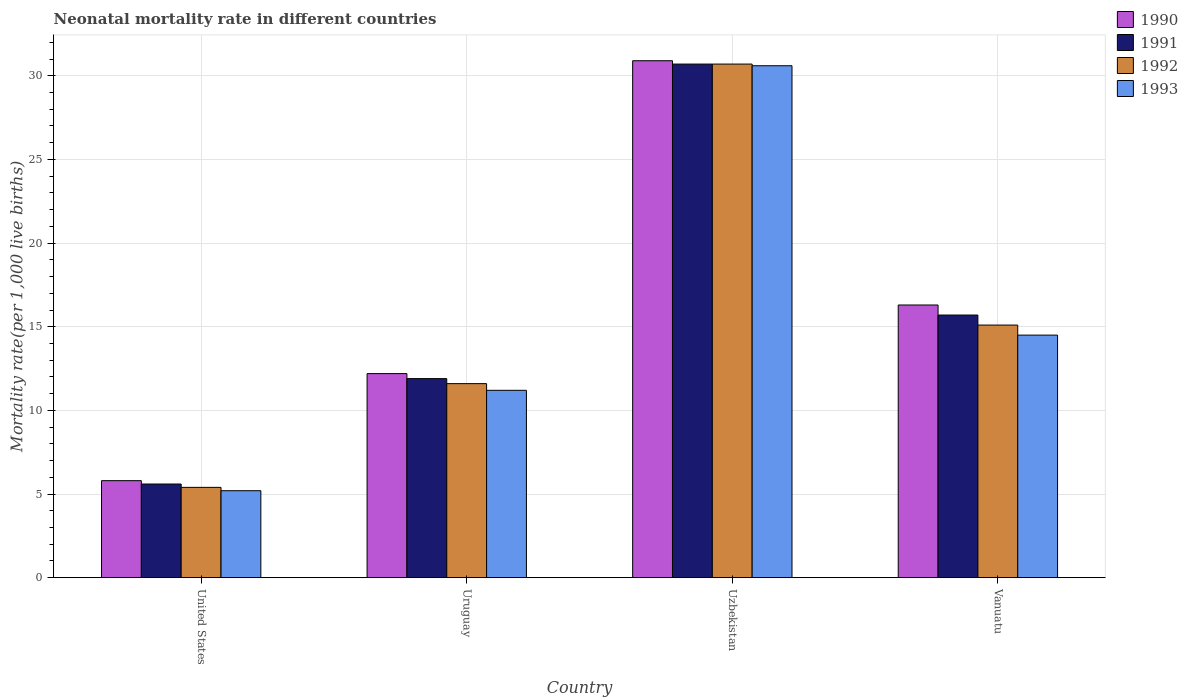Are the number of bars per tick equal to the number of legend labels?
Keep it short and to the point. Yes. What is the label of the 4th group of bars from the left?
Offer a very short reply. Vanuatu. In how many cases, is the number of bars for a given country not equal to the number of legend labels?
Keep it short and to the point. 0. Across all countries, what is the maximum neonatal mortality rate in 1992?
Give a very brief answer. 30.7. In which country was the neonatal mortality rate in 1991 maximum?
Provide a succinct answer. Uzbekistan. What is the total neonatal mortality rate in 1990 in the graph?
Give a very brief answer. 65.2. What is the difference between the neonatal mortality rate in 1992 in United States and that in Uruguay?
Your response must be concise. -6.2. What is the difference between the neonatal mortality rate in 1993 in Uruguay and the neonatal mortality rate in 1991 in United States?
Offer a terse response. 5.6. What is the average neonatal mortality rate in 1993 per country?
Give a very brief answer. 15.38. What is the difference between the neonatal mortality rate of/in 1990 and neonatal mortality rate of/in 1991 in United States?
Offer a terse response. 0.2. In how many countries, is the neonatal mortality rate in 1992 greater than 5?
Make the answer very short. 4. What is the ratio of the neonatal mortality rate in 1991 in United States to that in Uruguay?
Keep it short and to the point. 0.47. Is the neonatal mortality rate in 1990 in United States less than that in Uruguay?
Keep it short and to the point. Yes. Is the difference between the neonatal mortality rate in 1990 in United States and Uzbekistan greater than the difference between the neonatal mortality rate in 1991 in United States and Uzbekistan?
Your answer should be very brief. Yes. What is the difference between the highest and the second highest neonatal mortality rate in 1991?
Your answer should be compact. -18.8. What is the difference between the highest and the lowest neonatal mortality rate in 1991?
Your answer should be compact. 25.1. Is it the case that in every country, the sum of the neonatal mortality rate in 1990 and neonatal mortality rate in 1993 is greater than the sum of neonatal mortality rate in 1992 and neonatal mortality rate in 1991?
Offer a very short reply. No. Is it the case that in every country, the sum of the neonatal mortality rate in 1992 and neonatal mortality rate in 1990 is greater than the neonatal mortality rate in 1993?
Make the answer very short. Yes. How many countries are there in the graph?
Ensure brevity in your answer.  4. What is the difference between two consecutive major ticks on the Y-axis?
Offer a terse response. 5. Are the values on the major ticks of Y-axis written in scientific E-notation?
Offer a very short reply. No. Does the graph contain grids?
Keep it short and to the point. Yes. How many legend labels are there?
Your response must be concise. 4. How are the legend labels stacked?
Provide a short and direct response. Vertical. What is the title of the graph?
Offer a very short reply. Neonatal mortality rate in different countries. What is the label or title of the Y-axis?
Provide a short and direct response. Mortality rate(per 1,0 live births). What is the Mortality rate(per 1,000 live births) of 1991 in United States?
Provide a short and direct response. 5.6. What is the Mortality rate(per 1,000 live births) of 1992 in United States?
Provide a succinct answer. 5.4. What is the Mortality rate(per 1,000 live births) in 1993 in United States?
Keep it short and to the point. 5.2. What is the Mortality rate(per 1,000 live births) of 1991 in Uruguay?
Your answer should be very brief. 11.9. What is the Mortality rate(per 1,000 live births) in 1993 in Uruguay?
Offer a terse response. 11.2. What is the Mortality rate(per 1,000 live births) in 1990 in Uzbekistan?
Provide a short and direct response. 30.9. What is the Mortality rate(per 1,000 live births) of 1991 in Uzbekistan?
Offer a terse response. 30.7. What is the Mortality rate(per 1,000 live births) of 1992 in Uzbekistan?
Your answer should be very brief. 30.7. What is the Mortality rate(per 1,000 live births) of 1993 in Uzbekistan?
Provide a short and direct response. 30.6. What is the Mortality rate(per 1,000 live births) of 1991 in Vanuatu?
Provide a succinct answer. 15.7. What is the Mortality rate(per 1,000 live births) of 1992 in Vanuatu?
Give a very brief answer. 15.1. What is the Mortality rate(per 1,000 live births) in 1993 in Vanuatu?
Keep it short and to the point. 14.5. Across all countries, what is the maximum Mortality rate(per 1,000 live births) of 1990?
Provide a short and direct response. 30.9. Across all countries, what is the maximum Mortality rate(per 1,000 live births) of 1991?
Offer a very short reply. 30.7. Across all countries, what is the maximum Mortality rate(per 1,000 live births) in 1992?
Offer a terse response. 30.7. Across all countries, what is the maximum Mortality rate(per 1,000 live births) in 1993?
Your answer should be very brief. 30.6. Across all countries, what is the minimum Mortality rate(per 1,000 live births) of 1992?
Your response must be concise. 5.4. What is the total Mortality rate(per 1,000 live births) of 1990 in the graph?
Offer a very short reply. 65.2. What is the total Mortality rate(per 1,000 live births) in 1991 in the graph?
Your answer should be very brief. 63.9. What is the total Mortality rate(per 1,000 live births) in 1992 in the graph?
Keep it short and to the point. 62.8. What is the total Mortality rate(per 1,000 live births) in 1993 in the graph?
Offer a very short reply. 61.5. What is the difference between the Mortality rate(per 1,000 live births) in 1990 in United States and that in Uzbekistan?
Your answer should be compact. -25.1. What is the difference between the Mortality rate(per 1,000 live births) in 1991 in United States and that in Uzbekistan?
Your response must be concise. -25.1. What is the difference between the Mortality rate(per 1,000 live births) of 1992 in United States and that in Uzbekistan?
Your answer should be very brief. -25.3. What is the difference between the Mortality rate(per 1,000 live births) in 1993 in United States and that in Uzbekistan?
Ensure brevity in your answer.  -25.4. What is the difference between the Mortality rate(per 1,000 live births) of 1990 in United States and that in Vanuatu?
Your response must be concise. -10.5. What is the difference between the Mortality rate(per 1,000 live births) of 1990 in Uruguay and that in Uzbekistan?
Provide a succinct answer. -18.7. What is the difference between the Mortality rate(per 1,000 live births) in 1991 in Uruguay and that in Uzbekistan?
Offer a very short reply. -18.8. What is the difference between the Mortality rate(per 1,000 live births) of 1992 in Uruguay and that in Uzbekistan?
Offer a terse response. -19.1. What is the difference between the Mortality rate(per 1,000 live births) of 1993 in Uruguay and that in Uzbekistan?
Offer a very short reply. -19.4. What is the difference between the Mortality rate(per 1,000 live births) of 1991 in Uruguay and that in Vanuatu?
Give a very brief answer. -3.8. What is the difference between the Mortality rate(per 1,000 live births) in 1992 in Uruguay and that in Vanuatu?
Provide a short and direct response. -3.5. What is the difference between the Mortality rate(per 1,000 live births) of 1991 in Uzbekistan and that in Vanuatu?
Ensure brevity in your answer.  15. What is the difference between the Mortality rate(per 1,000 live births) in 1990 in United States and the Mortality rate(per 1,000 live births) in 1992 in Uruguay?
Give a very brief answer. -5.8. What is the difference between the Mortality rate(per 1,000 live births) of 1990 in United States and the Mortality rate(per 1,000 live births) of 1993 in Uruguay?
Your response must be concise. -5.4. What is the difference between the Mortality rate(per 1,000 live births) in 1991 in United States and the Mortality rate(per 1,000 live births) in 1992 in Uruguay?
Your response must be concise. -6. What is the difference between the Mortality rate(per 1,000 live births) in 1991 in United States and the Mortality rate(per 1,000 live births) in 1993 in Uruguay?
Your answer should be very brief. -5.6. What is the difference between the Mortality rate(per 1,000 live births) of 1990 in United States and the Mortality rate(per 1,000 live births) of 1991 in Uzbekistan?
Your response must be concise. -24.9. What is the difference between the Mortality rate(per 1,000 live births) of 1990 in United States and the Mortality rate(per 1,000 live births) of 1992 in Uzbekistan?
Offer a terse response. -24.9. What is the difference between the Mortality rate(per 1,000 live births) of 1990 in United States and the Mortality rate(per 1,000 live births) of 1993 in Uzbekistan?
Provide a succinct answer. -24.8. What is the difference between the Mortality rate(per 1,000 live births) in 1991 in United States and the Mortality rate(per 1,000 live births) in 1992 in Uzbekistan?
Provide a short and direct response. -25.1. What is the difference between the Mortality rate(per 1,000 live births) of 1991 in United States and the Mortality rate(per 1,000 live births) of 1993 in Uzbekistan?
Offer a terse response. -25. What is the difference between the Mortality rate(per 1,000 live births) of 1992 in United States and the Mortality rate(per 1,000 live births) of 1993 in Uzbekistan?
Provide a short and direct response. -25.2. What is the difference between the Mortality rate(per 1,000 live births) of 1990 in United States and the Mortality rate(per 1,000 live births) of 1991 in Vanuatu?
Keep it short and to the point. -9.9. What is the difference between the Mortality rate(per 1,000 live births) in 1990 in United States and the Mortality rate(per 1,000 live births) in 1993 in Vanuatu?
Your response must be concise. -8.7. What is the difference between the Mortality rate(per 1,000 live births) of 1991 in United States and the Mortality rate(per 1,000 live births) of 1993 in Vanuatu?
Your response must be concise. -8.9. What is the difference between the Mortality rate(per 1,000 live births) in 1992 in United States and the Mortality rate(per 1,000 live births) in 1993 in Vanuatu?
Offer a very short reply. -9.1. What is the difference between the Mortality rate(per 1,000 live births) in 1990 in Uruguay and the Mortality rate(per 1,000 live births) in 1991 in Uzbekistan?
Your answer should be very brief. -18.5. What is the difference between the Mortality rate(per 1,000 live births) of 1990 in Uruguay and the Mortality rate(per 1,000 live births) of 1992 in Uzbekistan?
Provide a short and direct response. -18.5. What is the difference between the Mortality rate(per 1,000 live births) of 1990 in Uruguay and the Mortality rate(per 1,000 live births) of 1993 in Uzbekistan?
Your response must be concise. -18.4. What is the difference between the Mortality rate(per 1,000 live births) of 1991 in Uruguay and the Mortality rate(per 1,000 live births) of 1992 in Uzbekistan?
Offer a very short reply. -18.8. What is the difference between the Mortality rate(per 1,000 live births) of 1991 in Uruguay and the Mortality rate(per 1,000 live births) of 1993 in Uzbekistan?
Provide a short and direct response. -18.7. What is the difference between the Mortality rate(per 1,000 live births) of 1990 in Uruguay and the Mortality rate(per 1,000 live births) of 1992 in Vanuatu?
Make the answer very short. -2.9. What is the difference between the Mortality rate(per 1,000 live births) of 1990 in Uruguay and the Mortality rate(per 1,000 live births) of 1993 in Vanuatu?
Provide a short and direct response. -2.3. What is the difference between the Mortality rate(per 1,000 live births) in 1990 in Uzbekistan and the Mortality rate(per 1,000 live births) in 1993 in Vanuatu?
Make the answer very short. 16.4. What is the difference between the Mortality rate(per 1,000 live births) in 1991 in Uzbekistan and the Mortality rate(per 1,000 live births) in 1992 in Vanuatu?
Keep it short and to the point. 15.6. What is the difference between the Mortality rate(per 1,000 live births) of 1991 in Uzbekistan and the Mortality rate(per 1,000 live births) of 1993 in Vanuatu?
Your response must be concise. 16.2. What is the average Mortality rate(per 1,000 live births) in 1991 per country?
Your answer should be very brief. 15.97. What is the average Mortality rate(per 1,000 live births) in 1993 per country?
Your response must be concise. 15.38. What is the difference between the Mortality rate(per 1,000 live births) in 1990 and Mortality rate(per 1,000 live births) in 1992 in United States?
Give a very brief answer. 0.4. What is the difference between the Mortality rate(per 1,000 live births) in 1992 and Mortality rate(per 1,000 live births) in 1993 in United States?
Give a very brief answer. 0.2. What is the difference between the Mortality rate(per 1,000 live births) in 1990 and Mortality rate(per 1,000 live births) in 1992 in Uruguay?
Offer a very short reply. 0.6. What is the difference between the Mortality rate(per 1,000 live births) of 1990 and Mortality rate(per 1,000 live births) of 1993 in Uruguay?
Your response must be concise. 1. What is the difference between the Mortality rate(per 1,000 live births) in 1991 and Mortality rate(per 1,000 live births) in 1992 in Uruguay?
Ensure brevity in your answer.  0.3. What is the difference between the Mortality rate(per 1,000 live births) in 1990 and Mortality rate(per 1,000 live births) in 1992 in Uzbekistan?
Provide a succinct answer. 0.2. What is the difference between the Mortality rate(per 1,000 live births) of 1990 and Mortality rate(per 1,000 live births) of 1993 in Uzbekistan?
Ensure brevity in your answer.  0.3. What is the difference between the Mortality rate(per 1,000 live births) in 1992 and Mortality rate(per 1,000 live births) in 1993 in Uzbekistan?
Ensure brevity in your answer.  0.1. What is the difference between the Mortality rate(per 1,000 live births) in 1990 and Mortality rate(per 1,000 live births) in 1991 in Vanuatu?
Provide a succinct answer. 0.6. What is the difference between the Mortality rate(per 1,000 live births) in 1990 and Mortality rate(per 1,000 live births) in 1992 in Vanuatu?
Make the answer very short. 1.2. What is the difference between the Mortality rate(per 1,000 live births) of 1990 and Mortality rate(per 1,000 live births) of 1993 in Vanuatu?
Ensure brevity in your answer.  1.8. What is the difference between the Mortality rate(per 1,000 live births) in 1991 and Mortality rate(per 1,000 live births) in 1992 in Vanuatu?
Offer a very short reply. 0.6. What is the ratio of the Mortality rate(per 1,000 live births) in 1990 in United States to that in Uruguay?
Make the answer very short. 0.48. What is the ratio of the Mortality rate(per 1,000 live births) in 1991 in United States to that in Uruguay?
Offer a terse response. 0.47. What is the ratio of the Mortality rate(per 1,000 live births) in 1992 in United States to that in Uruguay?
Your response must be concise. 0.47. What is the ratio of the Mortality rate(per 1,000 live births) in 1993 in United States to that in Uruguay?
Ensure brevity in your answer.  0.46. What is the ratio of the Mortality rate(per 1,000 live births) of 1990 in United States to that in Uzbekistan?
Offer a terse response. 0.19. What is the ratio of the Mortality rate(per 1,000 live births) of 1991 in United States to that in Uzbekistan?
Ensure brevity in your answer.  0.18. What is the ratio of the Mortality rate(per 1,000 live births) in 1992 in United States to that in Uzbekistan?
Make the answer very short. 0.18. What is the ratio of the Mortality rate(per 1,000 live births) of 1993 in United States to that in Uzbekistan?
Offer a very short reply. 0.17. What is the ratio of the Mortality rate(per 1,000 live births) in 1990 in United States to that in Vanuatu?
Give a very brief answer. 0.36. What is the ratio of the Mortality rate(per 1,000 live births) of 1991 in United States to that in Vanuatu?
Offer a very short reply. 0.36. What is the ratio of the Mortality rate(per 1,000 live births) of 1992 in United States to that in Vanuatu?
Keep it short and to the point. 0.36. What is the ratio of the Mortality rate(per 1,000 live births) of 1993 in United States to that in Vanuatu?
Your answer should be compact. 0.36. What is the ratio of the Mortality rate(per 1,000 live births) of 1990 in Uruguay to that in Uzbekistan?
Ensure brevity in your answer.  0.39. What is the ratio of the Mortality rate(per 1,000 live births) in 1991 in Uruguay to that in Uzbekistan?
Give a very brief answer. 0.39. What is the ratio of the Mortality rate(per 1,000 live births) in 1992 in Uruguay to that in Uzbekistan?
Offer a terse response. 0.38. What is the ratio of the Mortality rate(per 1,000 live births) in 1993 in Uruguay to that in Uzbekistan?
Make the answer very short. 0.37. What is the ratio of the Mortality rate(per 1,000 live births) in 1990 in Uruguay to that in Vanuatu?
Provide a short and direct response. 0.75. What is the ratio of the Mortality rate(per 1,000 live births) in 1991 in Uruguay to that in Vanuatu?
Make the answer very short. 0.76. What is the ratio of the Mortality rate(per 1,000 live births) in 1992 in Uruguay to that in Vanuatu?
Offer a very short reply. 0.77. What is the ratio of the Mortality rate(per 1,000 live births) of 1993 in Uruguay to that in Vanuatu?
Your answer should be very brief. 0.77. What is the ratio of the Mortality rate(per 1,000 live births) of 1990 in Uzbekistan to that in Vanuatu?
Your response must be concise. 1.9. What is the ratio of the Mortality rate(per 1,000 live births) of 1991 in Uzbekistan to that in Vanuatu?
Your answer should be very brief. 1.96. What is the ratio of the Mortality rate(per 1,000 live births) of 1992 in Uzbekistan to that in Vanuatu?
Provide a succinct answer. 2.03. What is the ratio of the Mortality rate(per 1,000 live births) in 1993 in Uzbekistan to that in Vanuatu?
Provide a short and direct response. 2.11. What is the difference between the highest and the second highest Mortality rate(per 1,000 live births) of 1990?
Keep it short and to the point. 14.6. What is the difference between the highest and the second highest Mortality rate(per 1,000 live births) in 1992?
Your answer should be very brief. 15.6. What is the difference between the highest and the lowest Mortality rate(per 1,000 live births) in 1990?
Your answer should be compact. 25.1. What is the difference between the highest and the lowest Mortality rate(per 1,000 live births) in 1991?
Your answer should be compact. 25.1. What is the difference between the highest and the lowest Mortality rate(per 1,000 live births) of 1992?
Offer a very short reply. 25.3. What is the difference between the highest and the lowest Mortality rate(per 1,000 live births) in 1993?
Provide a short and direct response. 25.4. 